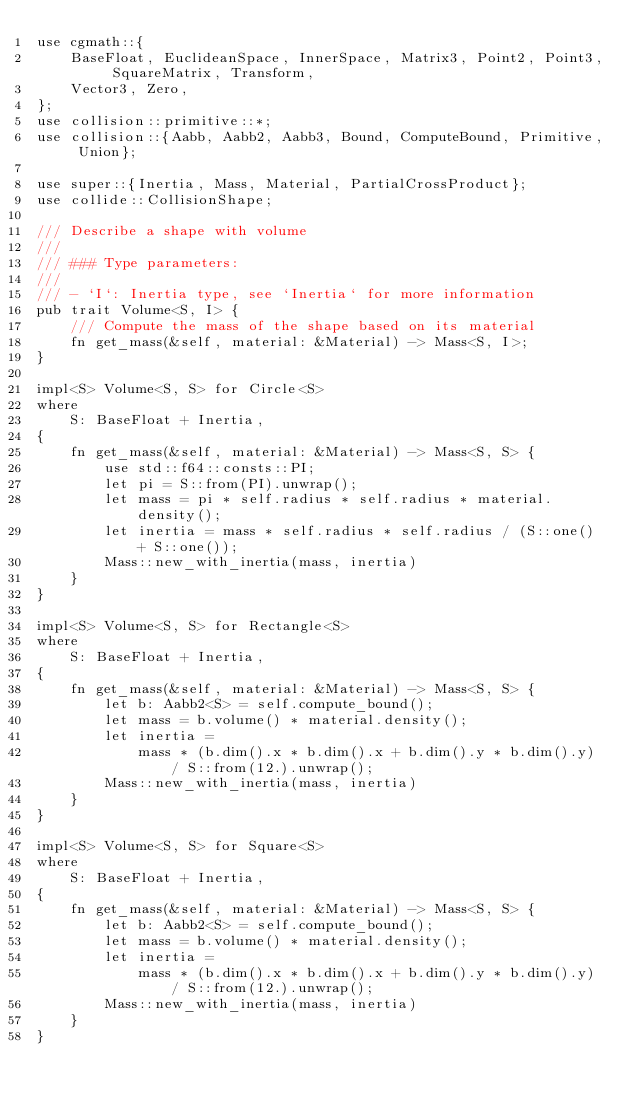Convert code to text. <code><loc_0><loc_0><loc_500><loc_500><_Rust_>use cgmath::{
    BaseFloat, EuclideanSpace, InnerSpace, Matrix3, Point2, Point3, SquareMatrix, Transform,
    Vector3, Zero,
};
use collision::primitive::*;
use collision::{Aabb, Aabb2, Aabb3, Bound, ComputeBound, Primitive, Union};

use super::{Inertia, Mass, Material, PartialCrossProduct};
use collide::CollisionShape;

/// Describe a shape with volume
///
/// ### Type parameters:
///
/// - `I`: Inertia type, see `Inertia` for more information
pub trait Volume<S, I> {
    /// Compute the mass of the shape based on its material
    fn get_mass(&self, material: &Material) -> Mass<S, I>;
}

impl<S> Volume<S, S> for Circle<S>
where
    S: BaseFloat + Inertia,
{
    fn get_mass(&self, material: &Material) -> Mass<S, S> {
        use std::f64::consts::PI;
        let pi = S::from(PI).unwrap();
        let mass = pi * self.radius * self.radius * material.density();
        let inertia = mass * self.radius * self.radius / (S::one() + S::one());
        Mass::new_with_inertia(mass, inertia)
    }
}

impl<S> Volume<S, S> for Rectangle<S>
where
    S: BaseFloat + Inertia,
{
    fn get_mass(&self, material: &Material) -> Mass<S, S> {
        let b: Aabb2<S> = self.compute_bound();
        let mass = b.volume() * material.density();
        let inertia =
            mass * (b.dim().x * b.dim().x + b.dim().y * b.dim().y) / S::from(12.).unwrap();
        Mass::new_with_inertia(mass, inertia)
    }
}

impl<S> Volume<S, S> for Square<S>
where
    S: BaseFloat + Inertia,
{
    fn get_mass(&self, material: &Material) -> Mass<S, S> {
        let b: Aabb2<S> = self.compute_bound();
        let mass = b.volume() * material.density();
        let inertia =
            mass * (b.dim().x * b.dim().x + b.dim().y * b.dim().y) / S::from(12.).unwrap();
        Mass::new_with_inertia(mass, inertia)
    }
}
</code> 